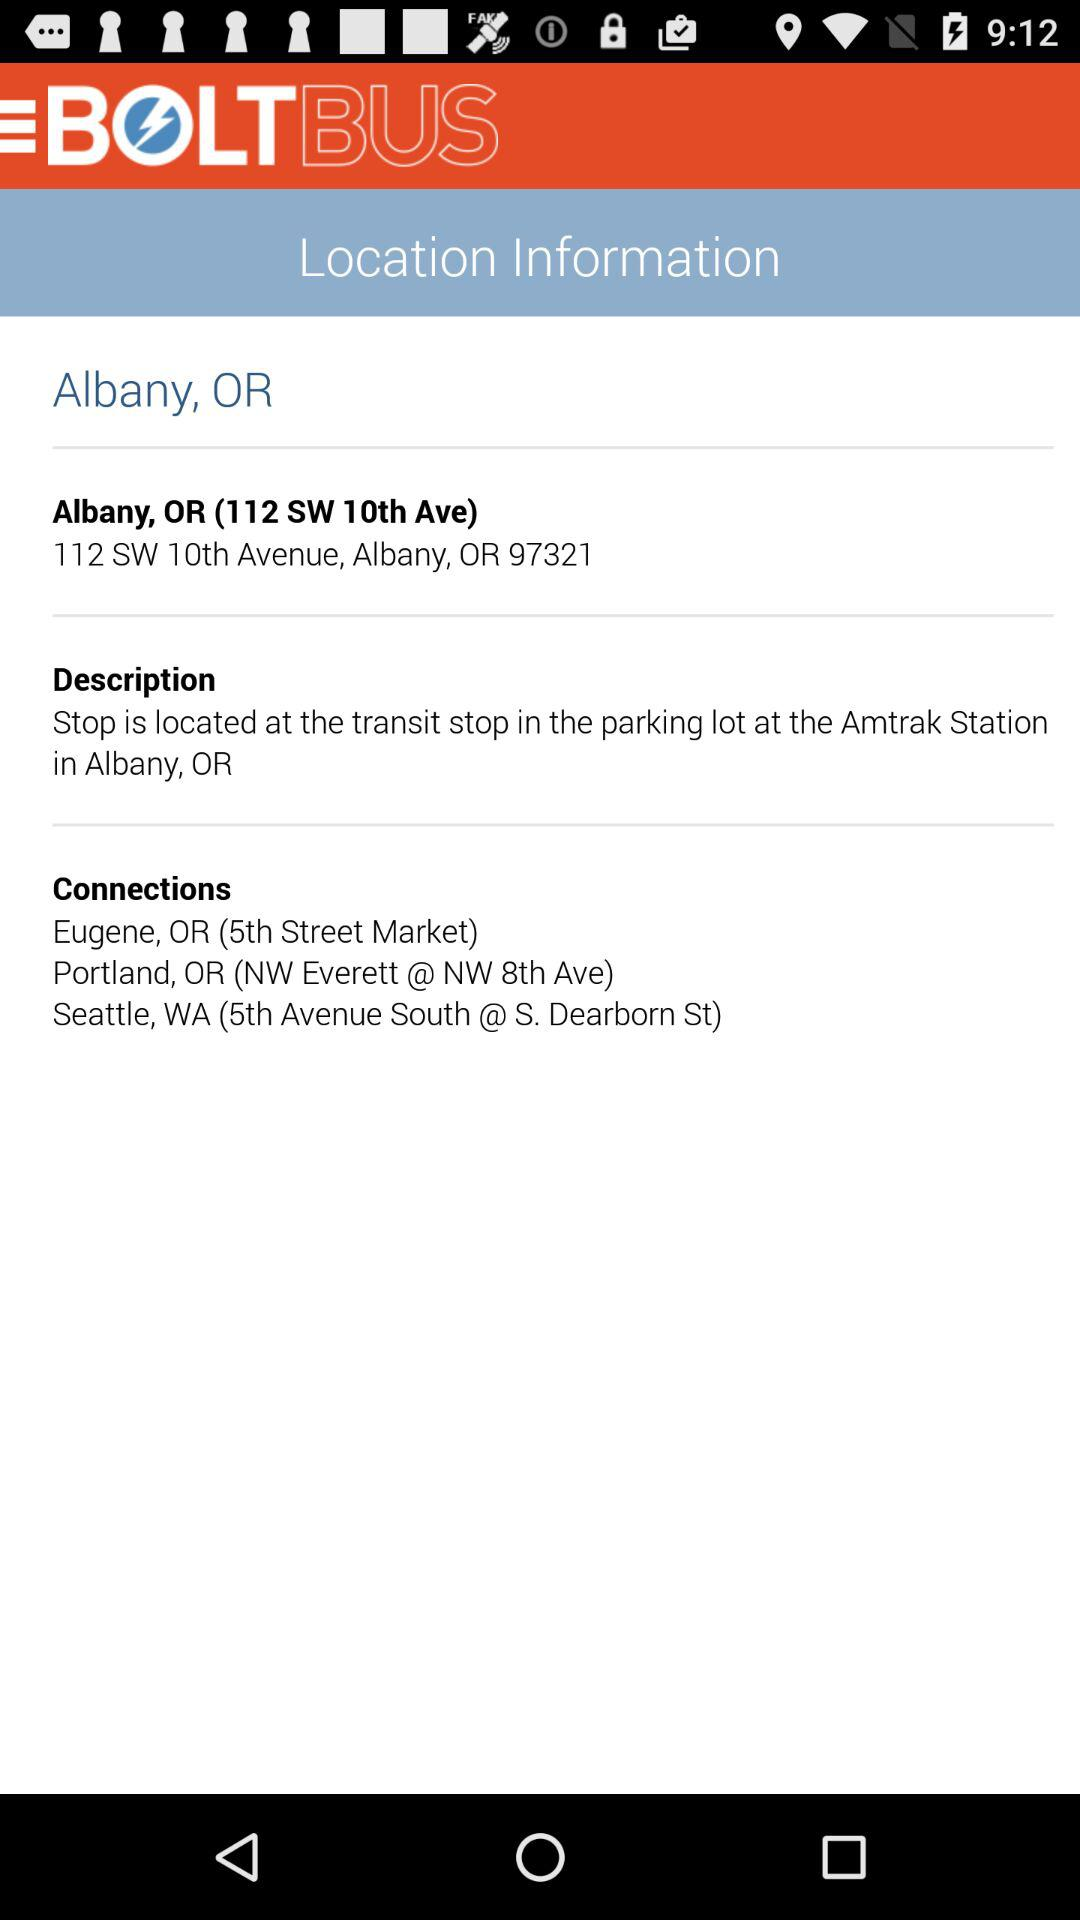What is the name of the application? The name of the application is "BOLTBUS". 